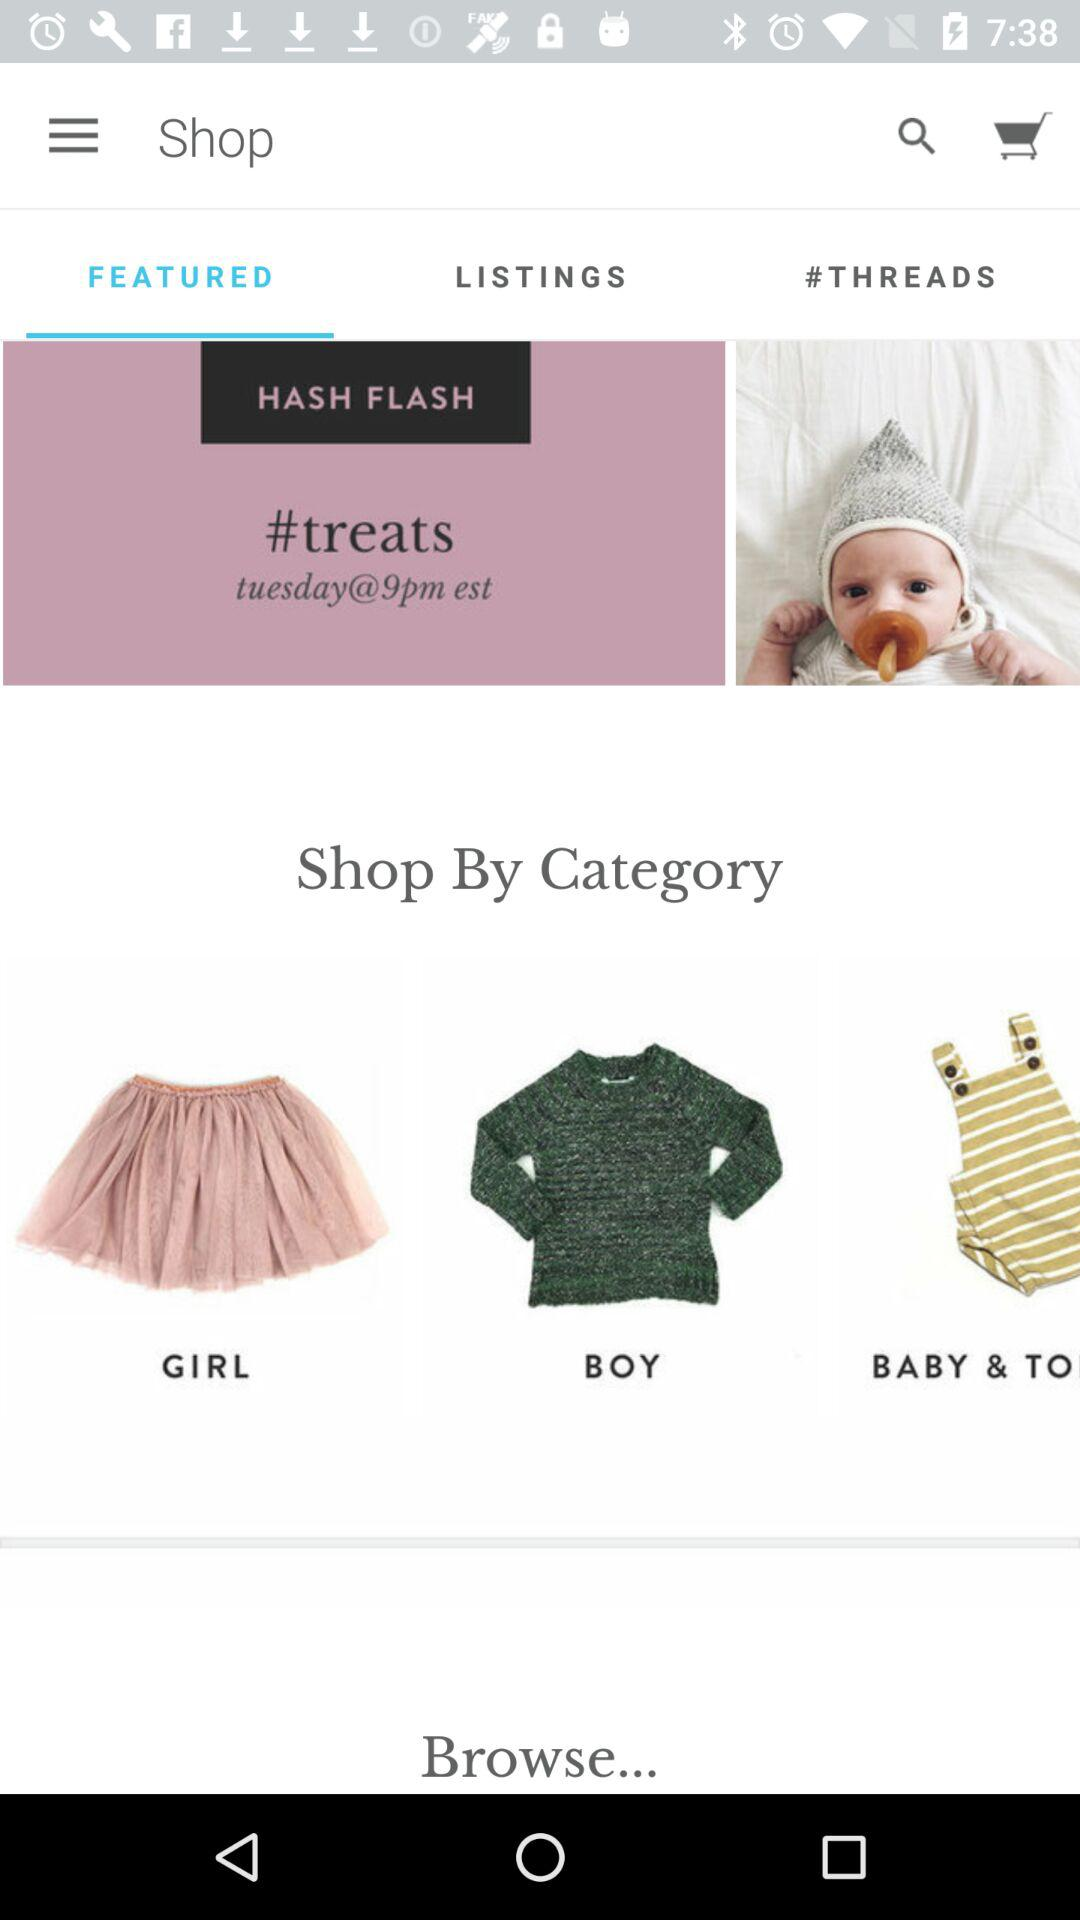What is the day and time? The day and time given is Tuesday at 9pm in European Standard Time. 